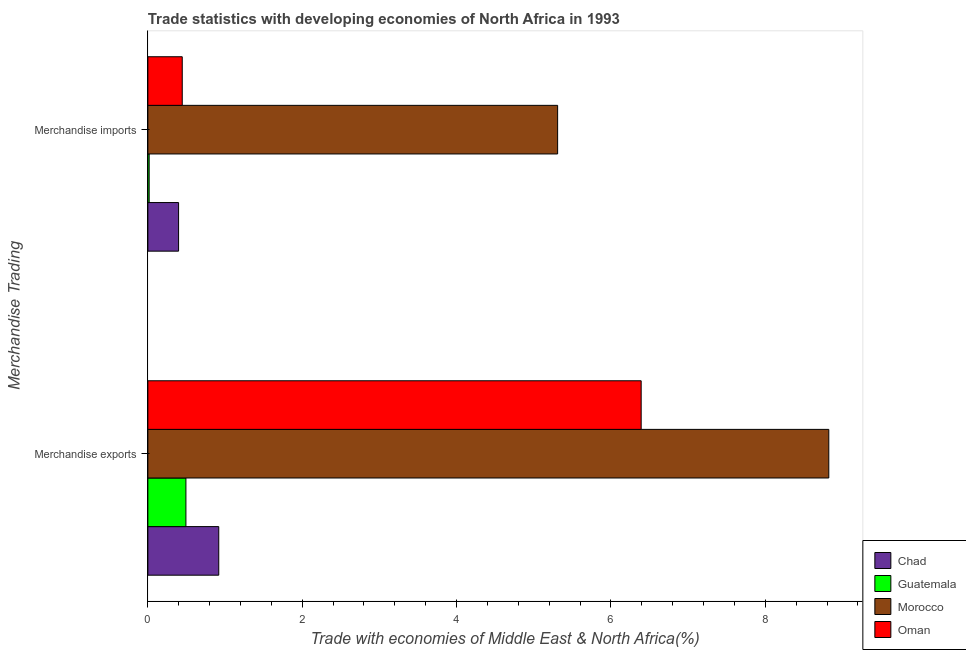Are the number of bars on each tick of the Y-axis equal?
Keep it short and to the point. Yes. How many bars are there on the 2nd tick from the bottom?
Provide a succinct answer. 4. What is the label of the 2nd group of bars from the top?
Give a very brief answer. Merchandise exports. What is the merchandise imports in Oman?
Provide a succinct answer. 0.45. Across all countries, what is the maximum merchandise imports?
Your answer should be compact. 5.31. Across all countries, what is the minimum merchandise exports?
Your response must be concise. 0.49. In which country was the merchandise exports maximum?
Keep it short and to the point. Morocco. In which country was the merchandise imports minimum?
Offer a very short reply. Guatemala. What is the total merchandise imports in the graph?
Your answer should be compact. 6.17. What is the difference between the merchandise exports in Chad and that in Guatemala?
Your response must be concise. 0.43. What is the difference between the merchandise imports in Morocco and the merchandise exports in Chad?
Your response must be concise. 4.39. What is the average merchandise imports per country?
Give a very brief answer. 1.54. What is the difference between the merchandise imports and merchandise exports in Morocco?
Offer a very short reply. -3.51. In how many countries, is the merchandise imports greater than 2.8 %?
Provide a short and direct response. 1. What is the ratio of the merchandise exports in Guatemala to that in Chad?
Ensure brevity in your answer.  0.54. Is the merchandise imports in Morocco less than that in Guatemala?
Give a very brief answer. No. In how many countries, is the merchandise imports greater than the average merchandise imports taken over all countries?
Provide a short and direct response. 1. What does the 4th bar from the top in Merchandise imports represents?
Offer a very short reply. Chad. What does the 3rd bar from the bottom in Merchandise imports represents?
Your response must be concise. Morocco. How many bars are there?
Keep it short and to the point. 8. Are all the bars in the graph horizontal?
Your response must be concise. Yes. What is the difference between two consecutive major ticks on the X-axis?
Offer a terse response. 2. Does the graph contain any zero values?
Your answer should be compact. No. Does the graph contain grids?
Give a very brief answer. No. How many legend labels are there?
Your response must be concise. 4. How are the legend labels stacked?
Your answer should be compact. Vertical. What is the title of the graph?
Your answer should be very brief. Trade statistics with developing economies of North Africa in 1993. What is the label or title of the X-axis?
Provide a short and direct response. Trade with economies of Middle East & North Africa(%). What is the label or title of the Y-axis?
Provide a short and direct response. Merchandise Trading. What is the Trade with economies of Middle East & North Africa(%) of Chad in Merchandise exports?
Your answer should be very brief. 0.92. What is the Trade with economies of Middle East & North Africa(%) of Guatemala in Merchandise exports?
Provide a succinct answer. 0.49. What is the Trade with economies of Middle East & North Africa(%) of Morocco in Merchandise exports?
Provide a succinct answer. 8.82. What is the Trade with economies of Middle East & North Africa(%) of Oman in Merchandise exports?
Your answer should be very brief. 6.39. What is the Trade with economies of Middle East & North Africa(%) in Chad in Merchandise imports?
Keep it short and to the point. 0.4. What is the Trade with economies of Middle East & North Africa(%) in Guatemala in Merchandise imports?
Provide a succinct answer. 0.02. What is the Trade with economies of Middle East & North Africa(%) of Morocco in Merchandise imports?
Give a very brief answer. 5.31. What is the Trade with economies of Middle East & North Africa(%) in Oman in Merchandise imports?
Make the answer very short. 0.45. Across all Merchandise Trading, what is the maximum Trade with economies of Middle East & North Africa(%) of Chad?
Offer a very short reply. 0.92. Across all Merchandise Trading, what is the maximum Trade with economies of Middle East & North Africa(%) in Guatemala?
Offer a very short reply. 0.49. Across all Merchandise Trading, what is the maximum Trade with economies of Middle East & North Africa(%) of Morocco?
Give a very brief answer. 8.82. Across all Merchandise Trading, what is the maximum Trade with economies of Middle East & North Africa(%) of Oman?
Provide a short and direct response. 6.39. Across all Merchandise Trading, what is the minimum Trade with economies of Middle East & North Africa(%) of Chad?
Your answer should be compact. 0.4. Across all Merchandise Trading, what is the minimum Trade with economies of Middle East & North Africa(%) in Guatemala?
Give a very brief answer. 0.02. Across all Merchandise Trading, what is the minimum Trade with economies of Middle East & North Africa(%) of Morocco?
Offer a very short reply. 5.31. Across all Merchandise Trading, what is the minimum Trade with economies of Middle East & North Africa(%) of Oman?
Keep it short and to the point. 0.45. What is the total Trade with economies of Middle East & North Africa(%) of Chad in the graph?
Your response must be concise. 1.32. What is the total Trade with economies of Middle East & North Africa(%) in Guatemala in the graph?
Provide a short and direct response. 0.51. What is the total Trade with economies of Middle East & North Africa(%) of Morocco in the graph?
Ensure brevity in your answer.  14.13. What is the total Trade with economies of Middle East & North Africa(%) of Oman in the graph?
Your answer should be very brief. 6.84. What is the difference between the Trade with economies of Middle East & North Africa(%) in Chad in Merchandise exports and that in Merchandise imports?
Your answer should be very brief. 0.52. What is the difference between the Trade with economies of Middle East & North Africa(%) of Guatemala in Merchandise exports and that in Merchandise imports?
Keep it short and to the point. 0.48. What is the difference between the Trade with economies of Middle East & North Africa(%) of Morocco in Merchandise exports and that in Merchandise imports?
Make the answer very short. 3.51. What is the difference between the Trade with economies of Middle East & North Africa(%) in Oman in Merchandise exports and that in Merchandise imports?
Provide a succinct answer. 5.95. What is the difference between the Trade with economies of Middle East & North Africa(%) of Chad in Merchandise exports and the Trade with economies of Middle East & North Africa(%) of Guatemala in Merchandise imports?
Offer a terse response. 0.9. What is the difference between the Trade with economies of Middle East & North Africa(%) of Chad in Merchandise exports and the Trade with economies of Middle East & North Africa(%) of Morocco in Merchandise imports?
Give a very brief answer. -4.39. What is the difference between the Trade with economies of Middle East & North Africa(%) in Chad in Merchandise exports and the Trade with economies of Middle East & North Africa(%) in Oman in Merchandise imports?
Make the answer very short. 0.47. What is the difference between the Trade with economies of Middle East & North Africa(%) of Guatemala in Merchandise exports and the Trade with economies of Middle East & North Africa(%) of Morocco in Merchandise imports?
Offer a very short reply. -4.82. What is the difference between the Trade with economies of Middle East & North Africa(%) in Guatemala in Merchandise exports and the Trade with economies of Middle East & North Africa(%) in Oman in Merchandise imports?
Provide a succinct answer. 0.05. What is the difference between the Trade with economies of Middle East & North Africa(%) in Morocco in Merchandise exports and the Trade with economies of Middle East & North Africa(%) in Oman in Merchandise imports?
Give a very brief answer. 8.38. What is the average Trade with economies of Middle East & North Africa(%) of Chad per Merchandise Trading?
Keep it short and to the point. 0.66. What is the average Trade with economies of Middle East & North Africa(%) in Guatemala per Merchandise Trading?
Give a very brief answer. 0.25. What is the average Trade with economies of Middle East & North Africa(%) in Morocco per Merchandise Trading?
Make the answer very short. 7.07. What is the average Trade with economies of Middle East & North Africa(%) of Oman per Merchandise Trading?
Keep it short and to the point. 3.42. What is the difference between the Trade with economies of Middle East & North Africa(%) in Chad and Trade with economies of Middle East & North Africa(%) in Guatemala in Merchandise exports?
Provide a succinct answer. 0.43. What is the difference between the Trade with economies of Middle East & North Africa(%) of Chad and Trade with economies of Middle East & North Africa(%) of Morocco in Merchandise exports?
Provide a succinct answer. -7.9. What is the difference between the Trade with economies of Middle East & North Africa(%) in Chad and Trade with economies of Middle East & North Africa(%) in Oman in Merchandise exports?
Provide a short and direct response. -5.47. What is the difference between the Trade with economies of Middle East & North Africa(%) of Guatemala and Trade with economies of Middle East & North Africa(%) of Morocco in Merchandise exports?
Offer a terse response. -8.33. What is the difference between the Trade with economies of Middle East & North Africa(%) of Guatemala and Trade with economies of Middle East & North Africa(%) of Oman in Merchandise exports?
Your answer should be compact. -5.9. What is the difference between the Trade with economies of Middle East & North Africa(%) of Morocco and Trade with economies of Middle East & North Africa(%) of Oman in Merchandise exports?
Your answer should be compact. 2.43. What is the difference between the Trade with economies of Middle East & North Africa(%) in Chad and Trade with economies of Middle East & North Africa(%) in Guatemala in Merchandise imports?
Provide a short and direct response. 0.38. What is the difference between the Trade with economies of Middle East & North Africa(%) of Chad and Trade with economies of Middle East & North Africa(%) of Morocco in Merchandise imports?
Your response must be concise. -4.91. What is the difference between the Trade with economies of Middle East & North Africa(%) of Chad and Trade with economies of Middle East & North Africa(%) of Oman in Merchandise imports?
Your answer should be compact. -0.05. What is the difference between the Trade with economies of Middle East & North Africa(%) in Guatemala and Trade with economies of Middle East & North Africa(%) in Morocco in Merchandise imports?
Provide a short and direct response. -5.29. What is the difference between the Trade with economies of Middle East & North Africa(%) of Guatemala and Trade with economies of Middle East & North Africa(%) of Oman in Merchandise imports?
Provide a succinct answer. -0.43. What is the difference between the Trade with economies of Middle East & North Africa(%) of Morocco and Trade with economies of Middle East & North Africa(%) of Oman in Merchandise imports?
Give a very brief answer. 4.86. What is the ratio of the Trade with economies of Middle East & North Africa(%) in Chad in Merchandise exports to that in Merchandise imports?
Offer a very short reply. 2.31. What is the ratio of the Trade with economies of Middle East & North Africa(%) of Guatemala in Merchandise exports to that in Merchandise imports?
Your answer should be compact. 29.29. What is the ratio of the Trade with economies of Middle East & North Africa(%) of Morocco in Merchandise exports to that in Merchandise imports?
Your response must be concise. 1.66. What is the ratio of the Trade with economies of Middle East & North Africa(%) in Oman in Merchandise exports to that in Merchandise imports?
Your answer should be compact. 14.34. What is the difference between the highest and the second highest Trade with economies of Middle East & North Africa(%) in Chad?
Give a very brief answer. 0.52. What is the difference between the highest and the second highest Trade with economies of Middle East & North Africa(%) in Guatemala?
Your answer should be very brief. 0.48. What is the difference between the highest and the second highest Trade with economies of Middle East & North Africa(%) of Morocco?
Your answer should be compact. 3.51. What is the difference between the highest and the second highest Trade with economies of Middle East & North Africa(%) in Oman?
Provide a short and direct response. 5.95. What is the difference between the highest and the lowest Trade with economies of Middle East & North Africa(%) of Chad?
Give a very brief answer. 0.52. What is the difference between the highest and the lowest Trade with economies of Middle East & North Africa(%) of Guatemala?
Keep it short and to the point. 0.48. What is the difference between the highest and the lowest Trade with economies of Middle East & North Africa(%) in Morocco?
Your answer should be very brief. 3.51. What is the difference between the highest and the lowest Trade with economies of Middle East & North Africa(%) of Oman?
Offer a very short reply. 5.95. 